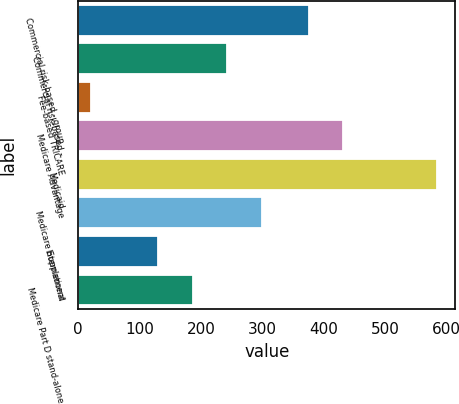Convert chart to OTSL. <chart><loc_0><loc_0><loc_500><loc_500><bar_chart><fcel>Commercial risk-based - group<fcel>Commercial risk-based -<fcel>Fee-based TRICARE<fcel>Medicare Advantage<fcel>Medicaid<fcel>Medicare Supplement<fcel>International<fcel>Medicare Part D stand-alone<nl><fcel>375<fcel>243<fcel>20<fcel>431.5<fcel>585<fcel>299.5<fcel>130<fcel>186.5<nl></chart> 